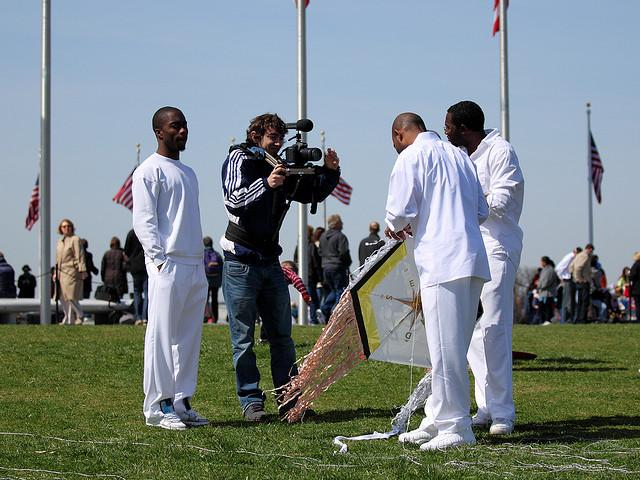What is the occupation of the man holding a camera?

Choices:
A) actor
B) athlete
C) film director
D) reporter reporter 